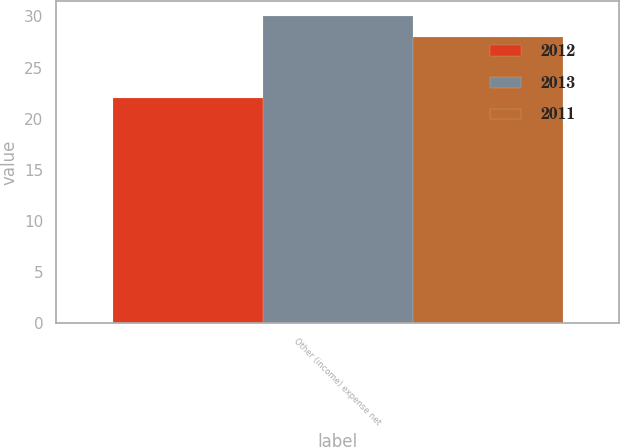Convert chart to OTSL. <chart><loc_0><loc_0><loc_500><loc_500><stacked_bar_chart><ecel><fcel>Other (income) expense net<nl><fcel>2012<fcel>22<nl><fcel>2013<fcel>30<nl><fcel>2011<fcel>28<nl></chart> 